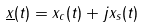Convert formula to latex. <formula><loc_0><loc_0><loc_500><loc_500>\underline { x } ( t ) = x _ { c } ( t ) + j x _ { s } ( t )</formula> 